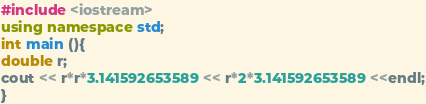Convert code to text. <code><loc_0><loc_0><loc_500><loc_500><_C++_>#include <iostream>
using namespace std;
int main (){
double r;
cout << r*r*3.141592653589 << r*2*3.141592653589 <<endl;
}

</code> 